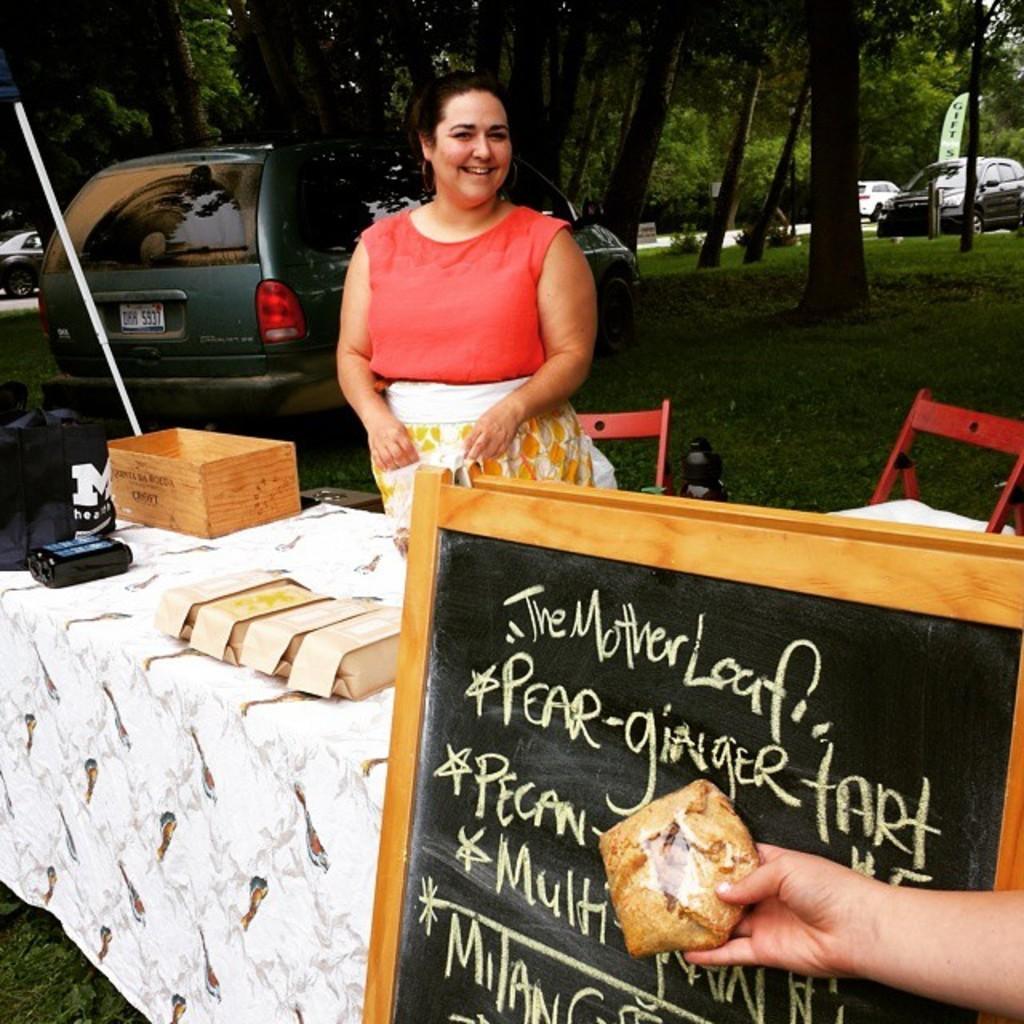In one or two sentences, can you explain what this image depicts? In this image, There is a table which is covered by a white cloth and there is a black color board and a person holding a food item, There is a woman standing behind the table, In the background there is a car of blue color and there are some trees of green color. 